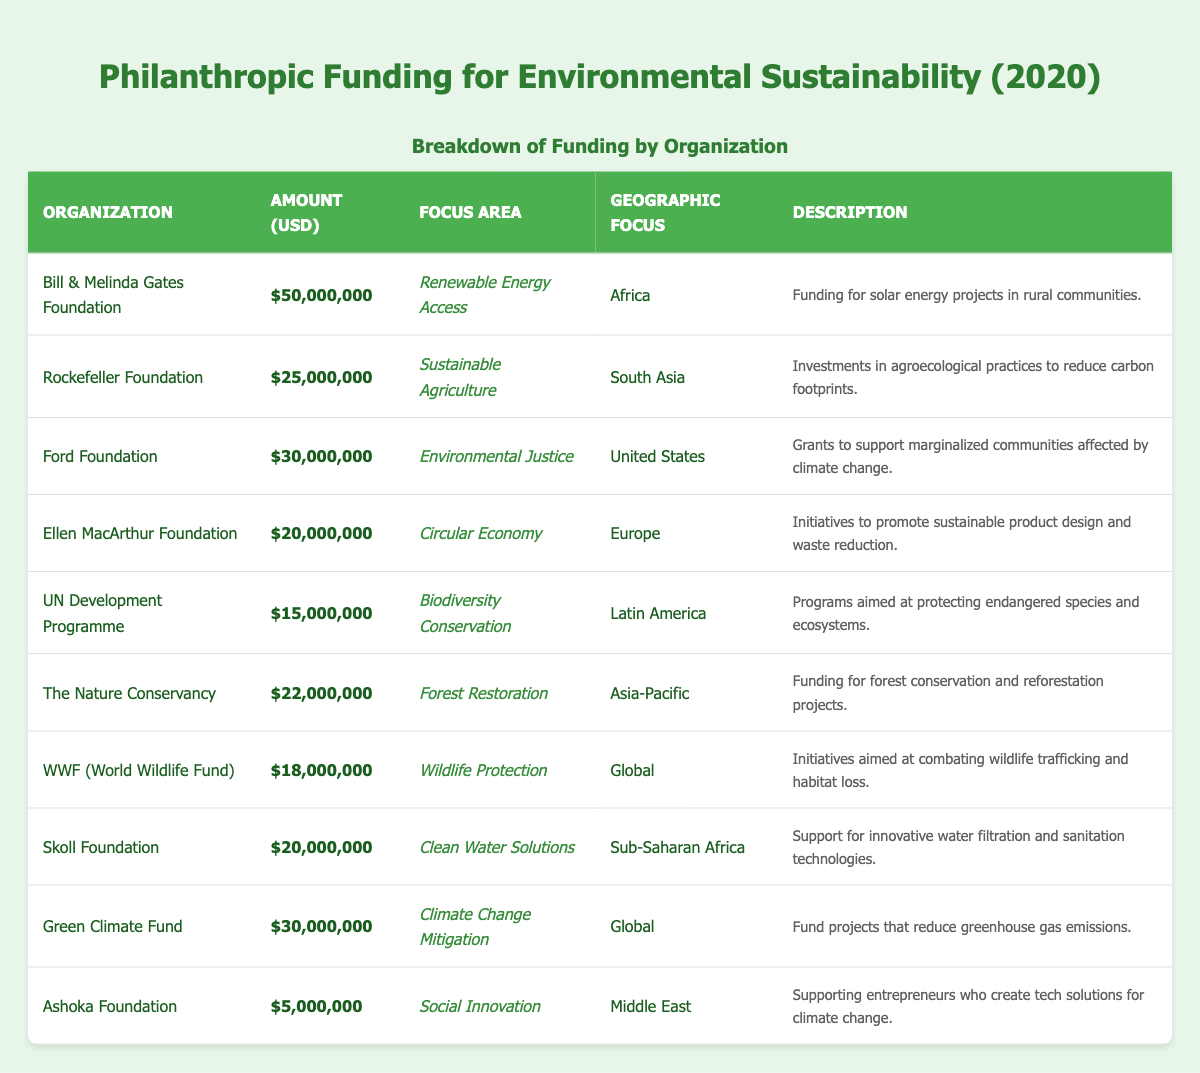What is the total amount of philanthropic funding listed in the table? To find the total amount, add all the funding amounts together: 50,000,000 + 25,000,000 + 30,000,000 + 20,000,000 + 15,000,000 + 22,000,000 + 18,000,000 + 20,000,000 + 30,000,000 + 5,000,000 = 235,000,000.
Answer: 235,000,000 Which organization received the highest funding amount? By scanning the "Amount (USD)" column, the Bill & Melinda Gates Foundation has the highest amount of 50,000,000.
Answer: Bill & Melinda Gates Foundation Are there any organizations focused on Wildlife Protection? Looking in the "Focus Area" column, WWF (World Wildlife Fund) is noted for Wildlife Protection.
Answer: Yes How much funding did organizations focusing on Climate Change Mitigation receive? The Green Climate Fund, focusing on Climate Change Mitigation, received 30,000,000. This is the only entry for that focus area, so it doesn’t need summation.
Answer: 30,000,000 What is the average amount of funding for organizations focused on Environmental Justice? Only the Ford Foundation focuses on Environmental Justice, with a funding of 30,000,000. Since there is only one data point, the average is the same as that amount.
Answer: 30,000,000 Which geographic region received the least funding? Inspecting the "Amount (USD)" column, the Ashoka Foundation in the Middle East received the least amount at 5,000,000.
Answer: Middle East What are the total funding amounts for organizations in Africa? The organizations that have a geographic focus on Africa are the Bill & Melinda Gates Foundation ($50,000,000) and the Skoll Foundation ($20,000,000). Adding these gives 50,000,000 + 20,000,000 = 70,000,000.
Answer: 70,000,000 Which focus area has the highest single funding amount after Renewable Energy Access? After Renewable Energy Access, the second highest amount is from the Ford Foundation under Environmental Justice with 30,000,000.
Answer: Environmental Justice Is the amount of funding for Sustainable Agriculture higher than that for Biodiversity Conservation? Sustainable Agriculture received 25,000,000, and Biodiversity Conservation received 15,000,000. Since 25,000,000 > 15,000,000, the statement is true.
Answer: Yes How many organizations focused on initiatives in the Asia-Pacific region? The table shows one organization with a focus area in the Asia-Pacific region: The Nature Conservancy.
Answer: 1 What percentage of total funding comes from the Ellen MacArthur Foundation? The Ellen MacArthur Foundation received 20,000,000. To calculate the percentage: (20,000,000 / 235,000,000) * 100 = 8.51%.
Answer: 8.51% What is the difference in funding amount between the highest and lowest funded organizations? The highest funded organization is the Bill & Melinda Gates Foundation with 50,000,000, and the lowest is the Ashoka Foundation with 5,000,000. The difference is 50,000,000 - 5,000,000 = 45,000,000.
Answer: 45,000,000 